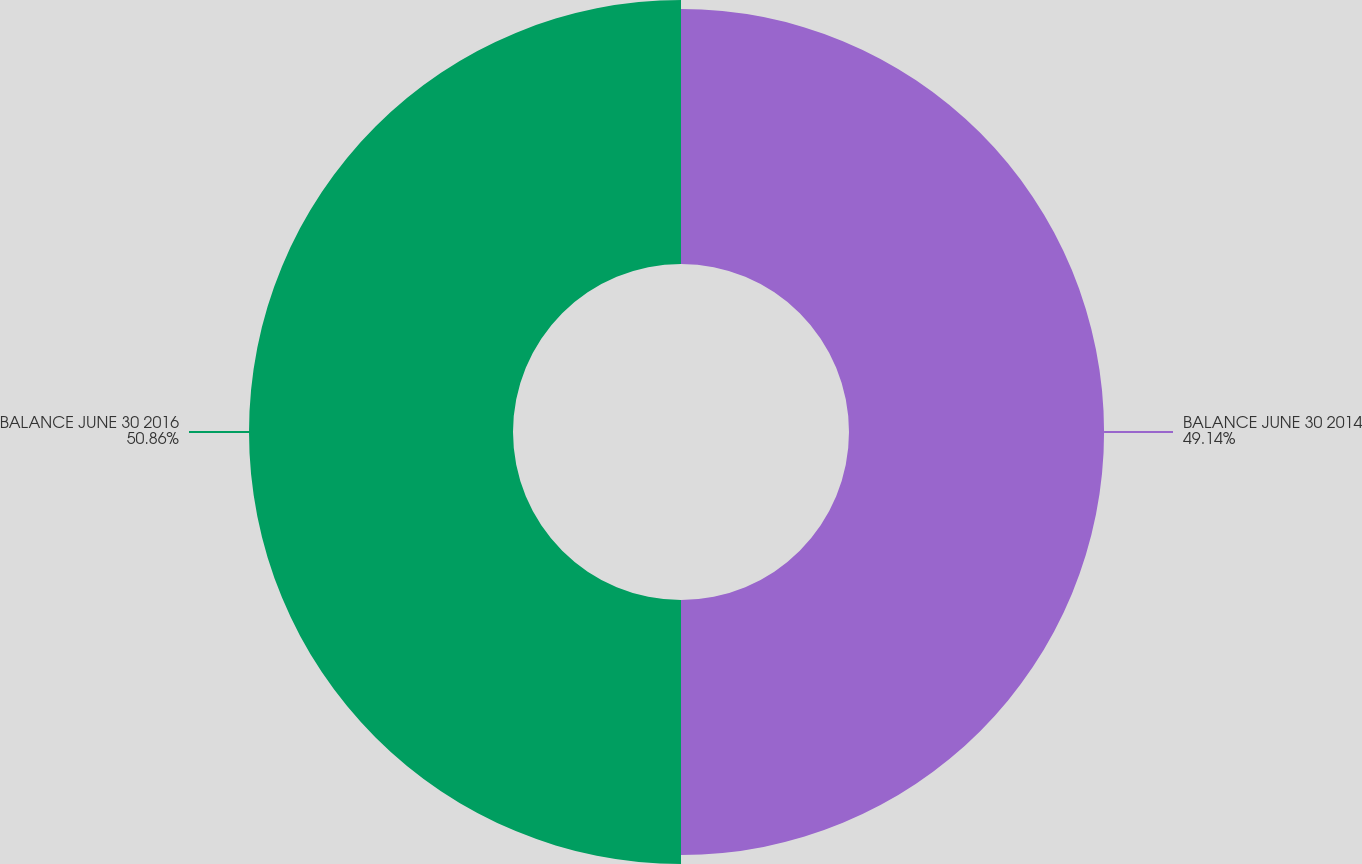Convert chart to OTSL. <chart><loc_0><loc_0><loc_500><loc_500><pie_chart><fcel>BALANCE JUNE 30 2014<fcel>BALANCE JUNE 30 2016<nl><fcel>49.14%<fcel>50.86%<nl></chart> 